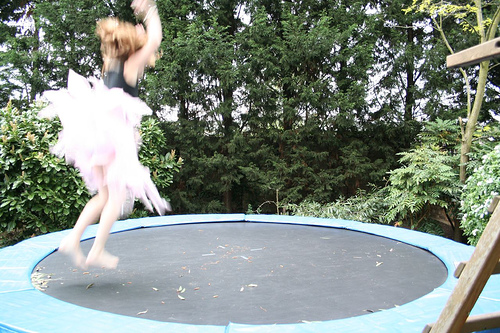Are the colors vibrant? The colors in the image are somewhat muted; the trampoline is a dark color and the surrounding foliage is various shades of green. While there's a burst of energy from the motion of the person jumping, the sense of vibrancy comes more from the action depicted than the color palette. 